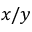<formula> <loc_0><loc_0><loc_500><loc_500>x / y</formula> 